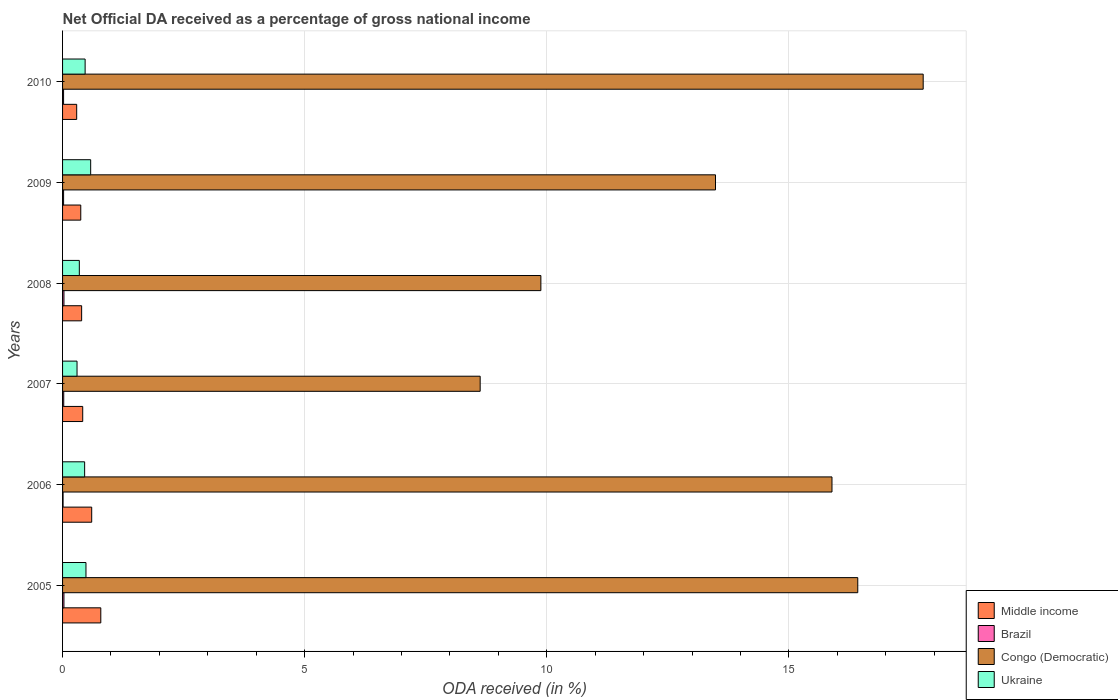How many groups of bars are there?
Offer a terse response. 6. Are the number of bars per tick equal to the number of legend labels?
Your response must be concise. Yes. Are the number of bars on each tick of the Y-axis equal?
Make the answer very short. Yes. What is the label of the 5th group of bars from the top?
Keep it short and to the point. 2006. What is the net official DA received in Middle income in 2009?
Give a very brief answer. 0.38. Across all years, what is the maximum net official DA received in Brazil?
Your answer should be compact. 0.03. Across all years, what is the minimum net official DA received in Middle income?
Your answer should be very brief. 0.29. In which year was the net official DA received in Middle income maximum?
Your response must be concise. 2005. In which year was the net official DA received in Middle income minimum?
Provide a short and direct response. 2010. What is the total net official DA received in Congo (Democratic) in the graph?
Your response must be concise. 82.08. What is the difference between the net official DA received in Ukraine in 2009 and that in 2010?
Provide a short and direct response. 0.11. What is the difference between the net official DA received in Ukraine in 2010 and the net official DA received in Middle income in 2005?
Offer a very short reply. -0.32. What is the average net official DA received in Middle income per year?
Ensure brevity in your answer.  0.48. In the year 2010, what is the difference between the net official DA received in Congo (Democratic) and net official DA received in Brazil?
Make the answer very short. 17.75. In how many years, is the net official DA received in Middle income greater than 9 %?
Offer a very short reply. 0. What is the ratio of the net official DA received in Ukraine in 2008 to that in 2009?
Keep it short and to the point. 0.6. Is the net official DA received in Congo (Democratic) in 2005 less than that in 2007?
Your answer should be very brief. No. What is the difference between the highest and the second highest net official DA received in Congo (Democratic)?
Your answer should be very brief. 1.35. What is the difference between the highest and the lowest net official DA received in Brazil?
Your response must be concise. 0.02. In how many years, is the net official DA received in Congo (Democratic) greater than the average net official DA received in Congo (Democratic) taken over all years?
Ensure brevity in your answer.  3. Is it the case that in every year, the sum of the net official DA received in Congo (Democratic) and net official DA received in Brazil is greater than the sum of net official DA received in Ukraine and net official DA received in Middle income?
Ensure brevity in your answer.  Yes. What does the 2nd bar from the top in 2009 represents?
Your response must be concise. Congo (Democratic). What does the 2nd bar from the bottom in 2008 represents?
Give a very brief answer. Brazil. Is it the case that in every year, the sum of the net official DA received in Brazil and net official DA received in Middle income is greater than the net official DA received in Ukraine?
Provide a succinct answer. No. How many bars are there?
Keep it short and to the point. 24. How many years are there in the graph?
Your answer should be very brief. 6. What is the difference between two consecutive major ticks on the X-axis?
Keep it short and to the point. 5. Are the values on the major ticks of X-axis written in scientific E-notation?
Provide a succinct answer. No. Does the graph contain grids?
Provide a succinct answer. Yes. Where does the legend appear in the graph?
Give a very brief answer. Bottom right. How many legend labels are there?
Make the answer very short. 4. What is the title of the graph?
Your answer should be compact. Net Official DA received as a percentage of gross national income. What is the label or title of the X-axis?
Provide a short and direct response. ODA received (in %). What is the label or title of the Y-axis?
Keep it short and to the point. Years. What is the ODA received (in %) of Middle income in 2005?
Your response must be concise. 0.79. What is the ODA received (in %) in Brazil in 2005?
Provide a succinct answer. 0.03. What is the ODA received (in %) in Congo (Democratic) in 2005?
Make the answer very short. 16.42. What is the ODA received (in %) of Ukraine in 2005?
Keep it short and to the point. 0.48. What is the ODA received (in %) in Middle income in 2006?
Ensure brevity in your answer.  0.6. What is the ODA received (in %) of Brazil in 2006?
Offer a terse response. 0.01. What is the ODA received (in %) in Congo (Democratic) in 2006?
Your response must be concise. 15.89. What is the ODA received (in %) in Ukraine in 2006?
Give a very brief answer. 0.46. What is the ODA received (in %) of Middle income in 2007?
Offer a terse response. 0.42. What is the ODA received (in %) of Brazil in 2007?
Offer a very short reply. 0.02. What is the ODA received (in %) in Congo (Democratic) in 2007?
Make the answer very short. 8.63. What is the ODA received (in %) of Ukraine in 2007?
Offer a very short reply. 0.3. What is the ODA received (in %) of Middle income in 2008?
Offer a terse response. 0.39. What is the ODA received (in %) in Brazil in 2008?
Offer a terse response. 0.03. What is the ODA received (in %) of Congo (Democratic) in 2008?
Keep it short and to the point. 9.88. What is the ODA received (in %) of Ukraine in 2008?
Make the answer very short. 0.35. What is the ODA received (in %) of Middle income in 2009?
Give a very brief answer. 0.38. What is the ODA received (in %) of Brazil in 2009?
Ensure brevity in your answer.  0.02. What is the ODA received (in %) of Congo (Democratic) in 2009?
Offer a very short reply. 13.49. What is the ODA received (in %) in Ukraine in 2009?
Your answer should be very brief. 0.58. What is the ODA received (in %) of Middle income in 2010?
Your answer should be compact. 0.29. What is the ODA received (in %) in Brazil in 2010?
Keep it short and to the point. 0.02. What is the ODA received (in %) of Congo (Democratic) in 2010?
Make the answer very short. 17.78. What is the ODA received (in %) of Ukraine in 2010?
Give a very brief answer. 0.47. Across all years, what is the maximum ODA received (in %) in Middle income?
Provide a short and direct response. 0.79. Across all years, what is the maximum ODA received (in %) in Brazil?
Provide a succinct answer. 0.03. Across all years, what is the maximum ODA received (in %) of Congo (Democratic)?
Keep it short and to the point. 17.78. Across all years, what is the maximum ODA received (in %) of Ukraine?
Provide a succinct answer. 0.58. Across all years, what is the minimum ODA received (in %) of Middle income?
Your answer should be very brief. 0.29. Across all years, what is the minimum ODA received (in %) of Brazil?
Your answer should be compact. 0.01. Across all years, what is the minimum ODA received (in %) in Congo (Democratic)?
Provide a succinct answer. 8.63. Across all years, what is the minimum ODA received (in %) in Ukraine?
Give a very brief answer. 0.3. What is the total ODA received (in %) of Middle income in the graph?
Give a very brief answer. 2.87. What is the total ODA received (in %) of Brazil in the graph?
Give a very brief answer. 0.13. What is the total ODA received (in %) of Congo (Democratic) in the graph?
Give a very brief answer. 82.08. What is the total ODA received (in %) in Ukraine in the graph?
Offer a terse response. 2.63. What is the difference between the ODA received (in %) in Middle income in 2005 and that in 2006?
Offer a very short reply. 0.19. What is the difference between the ODA received (in %) in Brazil in 2005 and that in 2006?
Offer a very short reply. 0.02. What is the difference between the ODA received (in %) of Congo (Democratic) in 2005 and that in 2006?
Your answer should be compact. 0.53. What is the difference between the ODA received (in %) of Ukraine in 2005 and that in 2006?
Your answer should be compact. 0.03. What is the difference between the ODA received (in %) in Middle income in 2005 and that in 2007?
Give a very brief answer. 0.37. What is the difference between the ODA received (in %) in Brazil in 2005 and that in 2007?
Your answer should be very brief. 0. What is the difference between the ODA received (in %) in Congo (Democratic) in 2005 and that in 2007?
Provide a short and direct response. 7.8. What is the difference between the ODA received (in %) in Ukraine in 2005 and that in 2007?
Offer a terse response. 0.18. What is the difference between the ODA received (in %) of Middle income in 2005 and that in 2008?
Keep it short and to the point. 0.4. What is the difference between the ODA received (in %) in Brazil in 2005 and that in 2008?
Provide a short and direct response. -0. What is the difference between the ODA received (in %) in Congo (Democratic) in 2005 and that in 2008?
Offer a terse response. 6.55. What is the difference between the ODA received (in %) in Ukraine in 2005 and that in 2008?
Offer a very short reply. 0.14. What is the difference between the ODA received (in %) in Middle income in 2005 and that in 2009?
Provide a succinct answer. 0.41. What is the difference between the ODA received (in %) in Brazil in 2005 and that in 2009?
Offer a terse response. 0.01. What is the difference between the ODA received (in %) of Congo (Democratic) in 2005 and that in 2009?
Your answer should be very brief. 2.94. What is the difference between the ODA received (in %) of Ukraine in 2005 and that in 2009?
Offer a terse response. -0.1. What is the difference between the ODA received (in %) in Middle income in 2005 and that in 2010?
Make the answer very short. 0.5. What is the difference between the ODA received (in %) of Brazil in 2005 and that in 2010?
Offer a very short reply. 0.01. What is the difference between the ODA received (in %) in Congo (Democratic) in 2005 and that in 2010?
Keep it short and to the point. -1.35. What is the difference between the ODA received (in %) in Ukraine in 2005 and that in 2010?
Provide a succinct answer. 0.02. What is the difference between the ODA received (in %) of Middle income in 2006 and that in 2007?
Provide a succinct answer. 0.19. What is the difference between the ODA received (in %) of Brazil in 2006 and that in 2007?
Ensure brevity in your answer.  -0.01. What is the difference between the ODA received (in %) in Congo (Democratic) in 2006 and that in 2007?
Provide a succinct answer. 7.27. What is the difference between the ODA received (in %) of Ukraine in 2006 and that in 2007?
Your response must be concise. 0.16. What is the difference between the ODA received (in %) in Middle income in 2006 and that in 2008?
Your response must be concise. 0.21. What is the difference between the ODA received (in %) in Brazil in 2006 and that in 2008?
Offer a terse response. -0.02. What is the difference between the ODA received (in %) of Congo (Democratic) in 2006 and that in 2008?
Make the answer very short. 6.01. What is the difference between the ODA received (in %) of Ukraine in 2006 and that in 2008?
Make the answer very short. 0.11. What is the difference between the ODA received (in %) in Middle income in 2006 and that in 2009?
Offer a very short reply. 0.23. What is the difference between the ODA received (in %) in Brazil in 2006 and that in 2009?
Offer a very short reply. -0.01. What is the difference between the ODA received (in %) of Congo (Democratic) in 2006 and that in 2009?
Provide a succinct answer. 2.41. What is the difference between the ODA received (in %) of Ukraine in 2006 and that in 2009?
Your answer should be compact. -0.12. What is the difference between the ODA received (in %) in Middle income in 2006 and that in 2010?
Offer a very short reply. 0.31. What is the difference between the ODA received (in %) in Brazil in 2006 and that in 2010?
Your answer should be very brief. -0.01. What is the difference between the ODA received (in %) of Congo (Democratic) in 2006 and that in 2010?
Your answer should be compact. -1.88. What is the difference between the ODA received (in %) of Ukraine in 2006 and that in 2010?
Offer a very short reply. -0.01. What is the difference between the ODA received (in %) of Middle income in 2007 and that in 2008?
Provide a succinct answer. 0.02. What is the difference between the ODA received (in %) in Brazil in 2007 and that in 2008?
Provide a short and direct response. -0. What is the difference between the ODA received (in %) in Congo (Democratic) in 2007 and that in 2008?
Your answer should be very brief. -1.25. What is the difference between the ODA received (in %) in Ukraine in 2007 and that in 2008?
Your response must be concise. -0.05. What is the difference between the ODA received (in %) of Middle income in 2007 and that in 2009?
Make the answer very short. 0.04. What is the difference between the ODA received (in %) of Brazil in 2007 and that in 2009?
Your response must be concise. 0. What is the difference between the ODA received (in %) of Congo (Democratic) in 2007 and that in 2009?
Give a very brief answer. -4.86. What is the difference between the ODA received (in %) in Ukraine in 2007 and that in 2009?
Offer a terse response. -0.28. What is the difference between the ODA received (in %) in Middle income in 2007 and that in 2010?
Keep it short and to the point. 0.12. What is the difference between the ODA received (in %) in Brazil in 2007 and that in 2010?
Provide a succinct answer. 0. What is the difference between the ODA received (in %) of Congo (Democratic) in 2007 and that in 2010?
Give a very brief answer. -9.15. What is the difference between the ODA received (in %) of Ukraine in 2007 and that in 2010?
Provide a short and direct response. -0.17. What is the difference between the ODA received (in %) of Middle income in 2008 and that in 2009?
Your response must be concise. 0.02. What is the difference between the ODA received (in %) of Brazil in 2008 and that in 2009?
Provide a short and direct response. 0.01. What is the difference between the ODA received (in %) in Congo (Democratic) in 2008 and that in 2009?
Give a very brief answer. -3.61. What is the difference between the ODA received (in %) in Ukraine in 2008 and that in 2009?
Provide a succinct answer. -0.23. What is the difference between the ODA received (in %) of Middle income in 2008 and that in 2010?
Make the answer very short. 0.1. What is the difference between the ODA received (in %) in Brazil in 2008 and that in 2010?
Give a very brief answer. 0.01. What is the difference between the ODA received (in %) of Congo (Democratic) in 2008 and that in 2010?
Provide a short and direct response. -7.9. What is the difference between the ODA received (in %) in Ukraine in 2008 and that in 2010?
Your answer should be compact. -0.12. What is the difference between the ODA received (in %) of Middle income in 2009 and that in 2010?
Make the answer very short. 0.08. What is the difference between the ODA received (in %) in Brazil in 2009 and that in 2010?
Make the answer very short. 0. What is the difference between the ODA received (in %) of Congo (Democratic) in 2009 and that in 2010?
Provide a succinct answer. -4.29. What is the difference between the ODA received (in %) in Ukraine in 2009 and that in 2010?
Provide a succinct answer. 0.11. What is the difference between the ODA received (in %) in Middle income in 2005 and the ODA received (in %) in Brazil in 2006?
Your answer should be very brief. 0.78. What is the difference between the ODA received (in %) of Middle income in 2005 and the ODA received (in %) of Congo (Democratic) in 2006?
Offer a terse response. -15.1. What is the difference between the ODA received (in %) in Middle income in 2005 and the ODA received (in %) in Ukraine in 2006?
Provide a short and direct response. 0.33. What is the difference between the ODA received (in %) of Brazil in 2005 and the ODA received (in %) of Congo (Democratic) in 2006?
Give a very brief answer. -15.86. What is the difference between the ODA received (in %) in Brazil in 2005 and the ODA received (in %) in Ukraine in 2006?
Your response must be concise. -0.43. What is the difference between the ODA received (in %) in Congo (Democratic) in 2005 and the ODA received (in %) in Ukraine in 2006?
Make the answer very short. 15.97. What is the difference between the ODA received (in %) of Middle income in 2005 and the ODA received (in %) of Brazil in 2007?
Offer a terse response. 0.77. What is the difference between the ODA received (in %) in Middle income in 2005 and the ODA received (in %) in Congo (Democratic) in 2007?
Give a very brief answer. -7.84. What is the difference between the ODA received (in %) of Middle income in 2005 and the ODA received (in %) of Ukraine in 2007?
Ensure brevity in your answer.  0.49. What is the difference between the ODA received (in %) in Brazil in 2005 and the ODA received (in %) in Congo (Democratic) in 2007?
Offer a terse response. -8.6. What is the difference between the ODA received (in %) of Brazil in 2005 and the ODA received (in %) of Ukraine in 2007?
Give a very brief answer. -0.27. What is the difference between the ODA received (in %) in Congo (Democratic) in 2005 and the ODA received (in %) in Ukraine in 2007?
Offer a very short reply. 16.13. What is the difference between the ODA received (in %) in Middle income in 2005 and the ODA received (in %) in Brazil in 2008?
Provide a succinct answer. 0.76. What is the difference between the ODA received (in %) in Middle income in 2005 and the ODA received (in %) in Congo (Democratic) in 2008?
Offer a very short reply. -9.09. What is the difference between the ODA received (in %) of Middle income in 2005 and the ODA received (in %) of Ukraine in 2008?
Your answer should be very brief. 0.44. What is the difference between the ODA received (in %) of Brazil in 2005 and the ODA received (in %) of Congo (Democratic) in 2008?
Offer a terse response. -9.85. What is the difference between the ODA received (in %) in Brazil in 2005 and the ODA received (in %) in Ukraine in 2008?
Give a very brief answer. -0.32. What is the difference between the ODA received (in %) of Congo (Democratic) in 2005 and the ODA received (in %) of Ukraine in 2008?
Offer a very short reply. 16.08. What is the difference between the ODA received (in %) of Middle income in 2005 and the ODA received (in %) of Brazil in 2009?
Offer a very short reply. 0.77. What is the difference between the ODA received (in %) of Middle income in 2005 and the ODA received (in %) of Congo (Democratic) in 2009?
Provide a succinct answer. -12.7. What is the difference between the ODA received (in %) in Middle income in 2005 and the ODA received (in %) in Ukraine in 2009?
Offer a very short reply. 0.21. What is the difference between the ODA received (in %) in Brazil in 2005 and the ODA received (in %) in Congo (Democratic) in 2009?
Make the answer very short. -13.46. What is the difference between the ODA received (in %) of Brazil in 2005 and the ODA received (in %) of Ukraine in 2009?
Give a very brief answer. -0.55. What is the difference between the ODA received (in %) of Congo (Democratic) in 2005 and the ODA received (in %) of Ukraine in 2009?
Make the answer very short. 15.84. What is the difference between the ODA received (in %) of Middle income in 2005 and the ODA received (in %) of Brazil in 2010?
Keep it short and to the point. 0.77. What is the difference between the ODA received (in %) of Middle income in 2005 and the ODA received (in %) of Congo (Democratic) in 2010?
Your answer should be very brief. -16.99. What is the difference between the ODA received (in %) of Middle income in 2005 and the ODA received (in %) of Ukraine in 2010?
Give a very brief answer. 0.32. What is the difference between the ODA received (in %) in Brazil in 2005 and the ODA received (in %) in Congo (Democratic) in 2010?
Provide a succinct answer. -17.75. What is the difference between the ODA received (in %) of Brazil in 2005 and the ODA received (in %) of Ukraine in 2010?
Make the answer very short. -0.44. What is the difference between the ODA received (in %) of Congo (Democratic) in 2005 and the ODA received (in %) of Ukraine in 2010?
Ensure brevity in your answer.  15.96. What is the difference between the ODA received (in %) of Middle income in 2006 and the ODA received (in %) of Brazil in 2007?
Your answer should be compact. 0.58. What is the difference between the ODA received (in %) in Middle income in 2006 and the ODA received (in %) in Congo (Democratic) in 2007?
Provide a succinct answer. -8.02. What is the difference between the ODA received (in %) in Middle income in 2006 and the ODA received (in %) in Ukraine in 2007?
Offer a very short reply. 0.3. What is the difference between the ODA received (in %) of Brazil in 2006 and the ODA received (in %) of Congo (Democratic) in 2007?
Provide a short and direct response. -8.61. What is the difference between the ODA received (in %) in Brazil in 2006 and the ODA received (in %) in Ukraine in 2007?
Give a very brief answer. -0.29. What is the difference between the ODA received (in %) in Congo (Democratic) in 2006 and the ODA received (in %) in Ukraine in 2007?
Your answer should be compact. 15.59. What is the difference between the ODA received (in %) in Middle income in 2006 and the ODA received (in %) in Brazil in 2008?
Offer a terse response. 0.57. What is the difference between the ODA received (in %) of Middle income in 2006 and the ODA received (in %) of Congo (Democratic) in 2008?
Offer a terse response. -9.28. What is the difference between the ODA received (in %) of Middle income in 2006 and the ODA received (in %) of Ukraine in 2008?
Offer a terse response. 0.26. What is the difference between the ODA received (in %) of Brazil in 2006 and the ODA received (in %) of Congo (Democratic) in 2008?
Your answer should be compact. -9.87. What is the difference between the ODA received (in %) of Brazil in 2006 and the ODA received (in %) of Ukraine in 2008?
Provide a short and direct response. -0.34. What is the difference between the ODA received (in %) of Congo (Democratic) in 2006 and the ODA received (in %) of Ukraine in 2008?
Provide a succinct answer. 15.55. What is the difference between the ODA received (in %) of Middle income in 2006 and the ODA received (in %) of Brazil in 2009?
Keep it short and to the point. 0.58. What is the difference between the ODA received (in %) of Middle income in 2006 and the ODA received (in %) of Congo (Democratic) in 2009?
Your answer should be very brief. -12.88. What is the difference between the ODA received (in %) of Middle income in 2006 and the ODA received (in %) of Ukraine in 2009?
Ensure brevity in your answer.  0.02. What is the difference between the ODA received (in %) of Brazil in 2006 and the ODA received (in %) of Congo (Democratic) in 2009?
Provide a succinct answer. -13.47. What is the difference between the ODA received (in %) in Brazil in 2006 and the ODA received (in %) in Ukraine in 2009?
Give a very brief answer. -0.57. What is the difference between the ODA received (in %) of Congo (Democratic) in 2006 and the ODA received (in %) of Ukraine in 2009?
Provide a short and direct response. 15.31. What is the difference between the ODA received (in %) in Middle income in 2006 and the ODA received (in %) in Brazil in 2010?
Make the answer very short. 0.58. What is the difference between the ODA received (in %) in Middle income in 2006 and the ODA received (in %) in Congo (Democratic) in 2010?
Your answer should be compact. -17.17. What is the difference between the ODA received (in %) in Middle income in 2006 and the ODA received (in %) in Ukraine in 2010?
Your answer should be very brief. 0.14. What is the difference between the ODA received (in %) of Brazil in 2006 and the ODA received (in %) of Congo (Democratic) in 2010?
Offer a terse response. -17.76. What is the difference between the ODA received (in %) of Brazil in 2006 and the ODA received (in %) of Ukraine in 2010?
Your answer should be very brief. -0.46. What is the difference between the ODA received (in %) in Congo (Democratic) in 2006 and the ODA received (in %) in Ukraine in 2010?
Your response must be concise. 15.43. What is the difference between the ODA received (in %) in Middle income in 2007 and the ODA received (in %) in Brazil in 2008?
Provide a short and direct response. 0.39. What is the difference between the ODA received (in %) in Middle income in 2007 and the ODA received (in %) in Congo (Democratic) in 2008?
Ensure brevity in your answer.  -9.46. What is the difference between the ODA received (in %) of Middle income in 2007 and the ODA received (in %) of Ukraine in 2008?
Make the answer very short. 0.07. What is the difference between the ODA received (in %) in Brazil in 2007 and the ODA received (in %) in Congo (Democratic) in 2008?
Give a very brief answer. -9.85. What is the difference between the ODA received (in %) in Brazil in 2007 and the ODA received (in %) in Ukraine in 2008?
Offer a terse response. -0.32. What is the difference between the ODA received (in %) of Congo (Democratic) in 2007 and the ODA received (in %) of Ukraine in 2008?
Your answer should be compact. 8.28. What is the difference between the ODA received (in %) in Middle income in 2007 and the ODA received (in %) in Brazil in 2009?
Provide a short and direct response. 0.39. What is the difference between the ODA received (in %) of Middle income in 2007 and the ODA received (in %) of Congo (Democratic) in 2009?
Make the answer very short. -13.07. What is the difference between the ODA received (in %) in Middle income in 2007 and the ODA received (in %) in Ukraine in 2009?
Offer a terse response. -0.16. What is the difference between the ODA received (in %) in Brazil in 2007 and the ODA received (in %) in Congo (Democratic) in 2009?
Offer a very short reply. -13.46. What is the difference between the ODA received (in %) of Brazil in 2007 and the ODA received (in %) of Ukraine in 2009?
Offer a terse response. -0.56. What is the difference between the ODA received (in %) in Congo (Democratic) in 2007 and the ODA received (in %) in Ukraine in 2009?
Ensure brevity in your answer.  8.04. What is the difference between the ODA received (in %) in Middle income in 2007 and the ODA received (in %) in Brazil in 2010?
Provide a short and direct response. 0.4. What is the difference between the ODA received (in %) in Middle income in 2007 and the ODA received (in %) in Congo (Democratic) in 2010?
Your answer should be compact. -17.36. What is the difference between the ODA received (in %) in Middle income in 2007 and the ODA received (in %) in Ukraine in 2010?
Keep it short and to the point. -0.05. What is the difference between the ODA received (in %) of Brazil in 2007 and the ODA received (in %) of Congo (Democratic) in 2010?
Keep it short and to the point. -17.75. What is the difference between the ODA received (in %) of Brazil in 2007 and the ODA received (in %) of Ukraine in 2010?
Give a very brief answer. -0.44. What is the difference between the ODA received (in %) of Congo (Democratic) in 2007 and the ODA received (in %) of Ukraine in 2010?
Give a very brief answer. 8.16. What is the difference between the ODA received (in %) in Middle income in 2008 and the ODA received (in %) in Brazil in 2009?
Provide a short and direct response. 0.37. What is the difference between the ODA received (in %) in Middle income in 2008 and the ODA received (in %) in Congo (Democratic) in 2009?
Offer a very short reply. -13.09. What is the difference between the ODA received (in %) in Middle income in 2008 and the ODA received (in %) in Ukraine in 2009?
Provide a short and direct response. -0.19. What is the difference between the ODA received (in %) of Brazil in 2008 and the ODA received (in %) of Congo (Democratic) in 2009?
Ensure brevity in your answer.  -13.46. What is the difference between the ODA received (in %) in Brazil in 2008 and the ODA received (in %) in Ukraine in 2009?
Make the answer very short. -0.55. What is the difference between the ODA received (in %) in Congo (Democratic) in 2008 and the ODA received (in %) in Ukraine in 2009?
Your response must be concise. 9.3. What is the difference between the ODA received (in %) in Middle income in 2008 and the ODA received (in %) in Brazil in 2010?
Your answer should be compact. 0.37. What is the difference between the ODA received (in %) of Middle income in 2008 and the ODA received (in %) of Congo (Democratic) in 2010?
Offer a very short reply. -17.38. What is the difference between the ODA received (in %) of Middle income in 2008 and the ODA received (in %) of Ukraine in 2010?
Give a very brief answer. -0.07. What is the difference between the ODA received (in %) in Brazil in 2008 and the ODA received (in %) in Congo (Democratic) in 2010?
Offer a very short reply. -17.75. What is the difference between the ODA received (in %) of Brazil in 2008 and the ODA received (in %) of Ukraine in 2010?
Ensure brevity in your answer.  -0.44. What is the difference between the ODA received (in %) of Congo (Democratic) in 2008 and the ODA received (in %) of Ukraine in 2010?
Provide a succinct answer. 9.41. What is the difference between the ODA received (in %) of Middle income in 2009 and the ODA received (in %) of Brazil in 2010?
Give a very brief answer. 0.36. What is the difference between the ODA received (in %) in Middle income in 2009 and the ODA received (in %) in Congo (Democratic) in 2010?
Your response must be concise. -17.4. What is the difference between the ODA received (in %) of Middle income in 2009 and the ODA received (in %) of Ukraine in 2010?
Offer a very short reply. -0.09. What is the difference between the ODA received (in %) in Brazil in 2009 and the ODA received (in %) in Congo (Democratic) in 2010?
Offer a terse response. -17.75. What is the difference between the ODA received (in %) in Brazil in 2009 and the ODA received (in %) in Ukraine in 2010?
Keep it short and to the point. -0.44. What is the difference between the ODA received (in %) of Congo (Democratic) in 2009 and the ODA received (in %) of Ukraine in 2010?
Your answer should be very brief. 13.02. What is the average ODA received (in %) in Middle income per year?
Your answer should be very brief. 0.48. What is the average ODA received (in %) of Brazil per year?
Your answer should be compact. 0.02. What is the average ODA received (in %) of Congo (Democratic) per year?
Your answer should be compact. 13.68. What is the average ODA received (in %) in Ukraine per year?
Give a very brief answer. 0.44. In the year 2005, what is the difference between the ODA received (in %) of Middle income and ODA received (in %) of Brazil?
Make the answer very short. 0.76. In the year 2005, what is the difference between the ODA received (in %) of Middle income and ODA received (in %) of Congo (Democratic)?
Your answer should be compact. -15.63. In the year 2005, what is the difference between the ODA received (in %) in Middle income and ODA received (in %) in Ukraine?
Keep it short and to the point. 0.31. In the year 2005, what is the difference between the ODA received (in %) in Brazil and ODA received (in %) in Congo (Democratic)?
Your response must be concise. -16.4. In the year 2005, what is the difference between the ODA received (in %) in Brazil and ODA received (in %) in Ukraine?
Provide a succinct answer. -0.46. In the year 2005, what is the difference between the ODA received (in %) in Congo (Democratic) and ODA received (in %) in Ukraine?
Give a very brief answer. 15.94. In the year 2006, what is the difference between the ODA received (in %) in Middle income and ODA received (in %) in Brazil?
Your response must be concise. 0.59. In the year 2006, what is the difference between the ODA received (in %) in Middle income and ODA received (in %) in Congo (Democratic)?
Keep it short and to the point. -15.29. In the year 2006, what is the difference between the ODA received (in %) in Middle income and ODA received (in %) in Ukraine?
Offer a very short reply. 0.15. In the year 2006, what is the difference between the ODA received (in %) of Brazil and ODA received (in %) of Congo (Democratic)?
Make the answer very short. -15.88. In the year 2006, what is the difference between the ODA received (in %) in Brazil and ODA received (in %) in Ukraine?
Keep it short and to the point. -0.45. In the year 2006, what is the difference between the ODA received (in %) in Congo (Democratic) and ODA received (in %) in Ukraine?
Offer a terse response. 15.44. In the year 2007, what is the difference between the ODA received (in %) in Middle income and ODA received (in %) in Brazil?
Offer a very short reply. 0.39. In the year 2007, what is the difference between the ODA received (in %) in Middle income and ODA received (in %) in Congo (Democratic)?
Ensure brevity in your answer.  -8.21. In the year 2007, what is the difference between the ODA received (in %) of Middle income and ODA received (in %) of Ukraine?
Your answer should be compact. 0.12. In the year 2007, what is the difference between the ODA received (in %) in Brazil and ODA received (in %) in Congo (Democratic)?
Provide a succinct answer. -8.6. In the year 2007, what is the difference between the ODA received (in %) in Brazil and ODA received (in %) in Ukraine?
Make the answer very short. -0.27. In the year 2007, what is the difference between the ODA received (in %) of Congo (Democratic) and ODA received (in %) of Ukraine?
Give a very brief answer. 8.33. In the year 2008, what is the difference between the ODA received (in %) in Middle income and ODA received (in %) in Brazil?
Provide a short and direct response. 0.37. In the year 2008, what is the difference between the ODA received (in %) in Middle income and ODA received (in %) in Congo (Democratic)?
Ensure brevity in your answer.  -9.48. In the year 2008, what is the difference between the ODA received (in %) in Middle income and ODA received (in %) in Ukraine?
Keep it short and to the point. 0.05. In the year 2008, what is the difference between the ODA received (in %) of Brazil and ODA received (in %) of Congo (Democratic)?
Make the answer very short. -9.85. In the year 2008, what is the difference between the ODA received (in %) of Brazil and ODA received (in %) of Ukraine?
Your answer should be very brief. -0.32. In the year 2008, what is the difference between the ODA received (in %) of Congo (Democratic) and ODA received (in %) of Ukraine?
Your response must be concise. 9.53. In the year 2009, what is the difference between the ODA received (in %) of Middle income and ODA received (in %) of Brazil?
Give a very brief answer. 0.35. In the year 2009, what is the difference between the ODA received (in %) in Middle income and ODA received (in %) in Congo (Democratic)?
Provide a succinct answer. -13.11. In the year 2009, what is the difference between the ODA received (in %) in Middle income and ODA received (in %) in Ukraine?
Provide a short and direct response. -0.2. In the year 2009, what is the difference between the ODA received (in %) of Brazil and ODA received (in %) of Congo (Democratic)?
Offer a very short reply. -13.46. In the year 2009, what is the difference between the ODA received (in %) of Brazil and ODA received (in %) of Ukraine?
Provide a succinct answer. -0.56. In the year 2009, what is the difference between the ODA received (in %) in Congo (Democratic) and ODA received (in %) in Ukraine?
Provide a succinct answer. 12.9. In the year 2010, what is the difference between the ODA received (in %) in Middle income and ODA received (in %) in Brazil?
Give a very brief answer. 0.27. In the year 2010, what is the difference between the ODA received (in %) in Middle income and ODA received (in %) in Congo (Democratic)?
Provide a short and direct response. -17.48. In the year 2010, what is the difference between the ODA received (in %) of Middle income and ODA received (in %) of Ukraine?
Your answer should be very brief. -0.17. In the year 2010, what is the difference between the ODA received (in %) in Brazil and ODA received (in %) in Congo (Democratic)?
Keep it short and to the point. -17.75. In the year 2010, what is the difference between the ODA received (in %) in Brazil and ODA received (in %) in Ukraine?
Offer a very short reply. -0.45. In the year 2010, what is the difference between the ODA received (in %) of Congo (Democratic) and ODA received (in %) of Ukraine?
Provide a succinct answer. 17.31. What is the ratio of the ODA received (in %) in Middle income in 2005 to that in 2006?
Your answer should be very brief. 1.31. What is the ratio of the ODA received (in %) of Brazil in 2005 to that in 2006?
Offer a very short reply. 2.66. What is the ratio of the ODA received (in %) of Congo (Democratic) in 2005 to that in 2006?
Offer a very short reply. 1.03. What is the ratio of the ODA received (in %) of Ukraine in 2005 to that in 2006?
Ensure brevity in your answer.  1.06. What is the ratio of the ODA received (in %) of Middle income in 2005 to that in 2007?
Offer a terse response. 1.9. What is the ratio of the ODA received (in %) in Brazil in 2005 to that in 2007?
Provide a succinct answer. 1.18. What is the ratio of the ODA received (in %) in Congo (Democratic) in 2005 to that in 2007?
Your response must be concise. 1.9. What is the ratio of the ODA received (in %) in Ukraine in 2005 to that in 2007?
Give a very brief answer. 1.62. What is the ratio of the ODA received (in %) of Middle income in 2005 to that in 2008?
Your answer should be compact. 2. What is the ratio of the ODA received (in %) in Brazil in 2005 to that in 2008?
Provide a succinct answer. 0.99. What is the ratio of the ODA received (in %) of Congo (Democratic) in 2005 to that in 2008?
Your answer should be compact. 1.66. What is the ratio of the ODA received (in %) of Ukraine in 2005 to that in 2008?
Make the answer very short. 1.4. What is the ratio of the ODA received (in %) in Middle income in 2005 to that in 2009?
Your answer should be compact. 2.1. What is the ratio of the ODA received (in %) of Brazil in 2005 to that in 2009?
Ensure brevity in your answer.  1.34. What is the ratio of the ODA received (in %) of Congo (Democratic) in 2005 to that in 2009?
Provide a succinct answer. 1.22. What is the ratio of the ODA received (in %) of Ukraine in 2005 to that in 2009?
Provide a succinct answer. 0.83. What is the ratio of the ODA received (in %) of Middle income in 2005 to that in 2010?
Give a very brief answer. 2.71. What is the ratio of the ODA received (in %) in Brazil in 2005 to that in 2010?
Provide a succinct answer. 1.36. What is the ratio of the ODA received (in %) in Congo (Democratic) in 2005 to that in 2010?
Give a very brief answer. 0.92. What is the ratio of the ODA received (in %) of Ukraine in 2005 to that in 2010?
Offer a very short reply. 1.04. What is the ratio of the ODA received (in %) in Middle income in 2006 to that in 2007?
Ensure brevity in your answer.  1.45. What is the ratio of the ODA received (in %) in Brazil in 2006 to that in 2007?
Provide a succinct answer. 0.45. What is the ratio of the ODA received (in %) of Congo (Democratic) in 2006 to that in 2007?
Keep it short and to the point. 1.84. What is the ratio of the ODA received (in %) of Ukraine in 2006 to that in 2007?
Offer a very short reply. 1.53. What is the ratio of the ODA received (in %) of Middle income in 2006 to that in 2008?
Provide a short and direct response. 1.53. What is the ratio of the ODA received (in %) in Brazil in 2006 to that in 2008?
Your answer should be compact. 0.37. What is the ratio of the ODA received (in %) in Congo (Democratic) in 2006 to that in 2008?
Your answer should be very brief. 1.61. What is the ratio of the ODA received (in %) of Ukraine in 2006 to that in 2008?
Offer a terse response. 1.32. What is the ratio of the ODA received (in %) of Middle income in 2006 to that in 2009?
Offer a very short reply. 1.6. What is the ratio of the ODA received (in %) in Brazil in 2006 to that in 2009?
Give a very brief answer. 0.5. What is the ratio of the ODA received (in %) in Congo (Democratic) in 2006 to that in 2009?
Your response must be concise. 1.18. What is the ratio of the ODA received (in %) of Ukraine in 2006 to that in 2009?
Offer a very short reply. 0.79. What is the ratio of the ODA received (in %) of Middle income in 2006 to that in 2010?
Your answer should be very brief. 2.06. What is the ratio of the ODA received (in %) in Brazil in 2006 to that in 2010?
Ensure brevity in your answer.  0.51. What is the ratio of the ODA received (in %) in Congo (Democratic) in 2006 to that in 2010?
Your response must be concise. 0.89. What is the ratio of the ODA received (in %) in Ukraine in 2006 to that in 2010?
Offer a very short reply. 0.98. What is the ratio of the ODA received (in %) in Middle income in 2007 to that in 2008?
Offer a very short reply. 1.06. What is the ratio of the ODA received (in %) in Brazil in 2007 to that in 2008?
Give a very brief answer. 0.84. What is the ratio of the ODA received (in %) in Congo (Democratic) in 2007 to that in 2008?
Your response must be concise. 0.87. What is the ratio of the ODA received (in %) of Ukraine in 2007 to that in 2008?
Give a very brief answer. 0.86. What is the ratio of the ODA received (in %) in Middle income in 2007 to that in 2009?
Keep it short and to the point. 1.11. What is the ratio of the ODA received (in %) in Brazil in 2007 to that in 2009?
Offer a very short reply. 1.13. What is the ratio of the ODA received (in %) in Congo (Democratic) in 2007 to that in 2009?
Ensure brevity in your answer.  0.64. What is the ratio of the ODA received (in %) in Ukraine in 2007 to that in 2009?
Keep it short and to the point. 0.52. What is the ratio of the ODA received (in %) of Middle income in 2007 to that in 2010?
Your answer should be very brief. 1.43. What is the ratio of the ODA received (in %) of Brazil in 2007 to that in 2010?
Your answer should be very brief. 1.15. What is the ratio of the ODA received (in %) of Congo (Democratic) in 2007 to that in 2010?
Keep it short and to the point. 0.49. What is the ratio of the ODA received (in %) of Ukraine in 2007 to that in 2010?
Provide a succinct answer. 0.64. What is the ratio of the ODA received (in %) of Middle income in 2008 to that in 2009?
Ensure brevity in your answer.  1.05. What is the ratio of the ODA received (in %) in Brazil in 2008 to that in 2009?
Offer a terse response. 1.34. What is the ratio of the ODA received (in %) of Congo (Democratic) in 2008 to that in 2009?
Make the answer very short. 0.73. What is the ratio of the ODA received (in %) in Ukraine in 2008 to that in 2009?
Provide a short and direct response. 0.6. What is the ratio of the ODA received (in %) in Middle income in 2008 to that in 2010?
Offer a terse response. 1.35. What is the ratio of the ODA received (in %) of Brazil in 2008 to that in 2010?
Your answer should be compact. 1.37. What is the ratio of the ODA received (in %) of Congo (Democratic) in 2008 to that in 2010?
Offer a terse response. 0.56. What is the ratio of the ODA received (in %) in Ukraine in 2008 to that in 2010?
Provide a short and direct response. 0.74. What is the ratio of the ODA received (in %) of Middle income in 2009 to that in 2010?
Offer a very short reply. 1.29. What is the ratio of the ODA received (in %) in Brazil in 2009 to that in 2010?
Give a very brief answer. 1.02. What is the ratio of the ODA received (in %) in Congo (Democratic) in 2009 to that in 2010?
Give a very brief answer. 0.76. What is the ratio of the ODA received (in %) in Ukraine in 2009 to that in 2010?
Give a very brief answer. 1.25. What is the difference between the highest and the second highest ODA received (in %) in Middle income?
Give a very brief answer. 0.19. What is the difference between the highest and the second highest ODA received (in %) of Brazil?
Offer a very short reply. 0. What is the difference between the highest and the second highest ODA received (in %) of Congo (Democratic)?
Your answer should be compact. 1.35. What is the difference between the highest and the second highest ODA received (in %) in Ukraine?
Offer a terse response. 0.1. What is the difference between the highest and the lowest ODA received (in %) of Middle income?
Give a very brief answer. 0.5. What is the difference between the highest and the lowest ODA received (in %) in Brazil?
Ensure brevity in your answer.  0.02. What is the difference between the highest and the lowest ODA received (in %) in Congo (Democratic)?
Provide a succinct answer. 9.15. What is the difference between the highest and the lowest ODA received (in %) of Ukraine?
Make the answer very short. 0.28. 